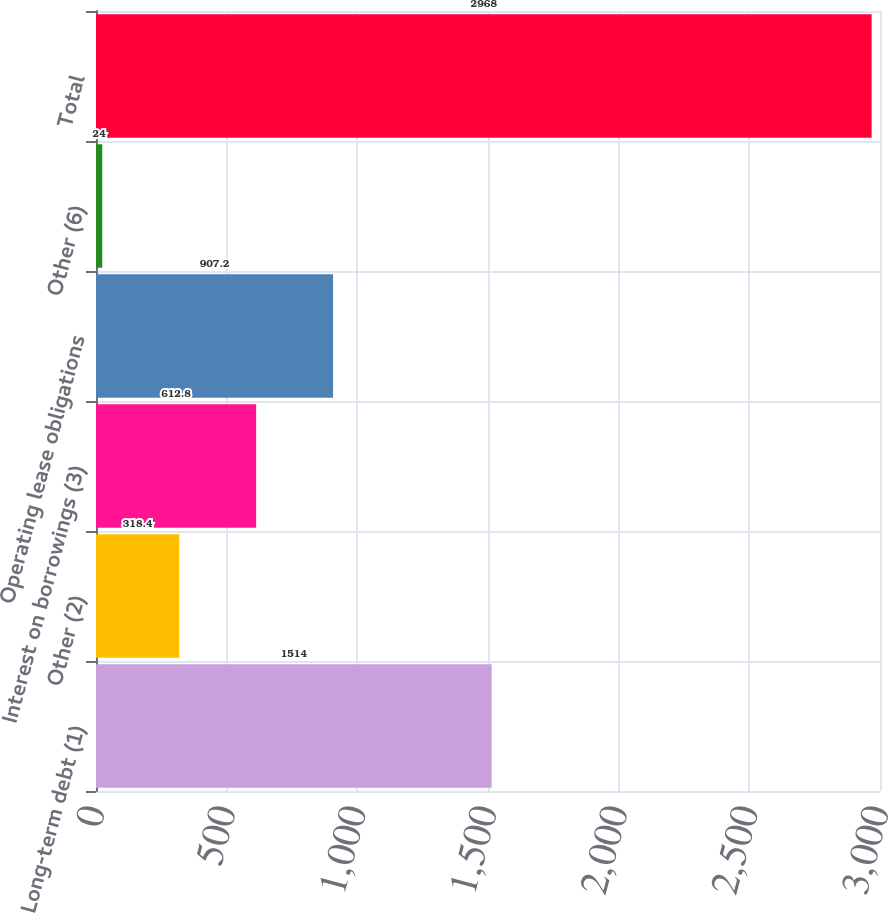Convert chart to OTSL. <chart><loc_0><loc_0><loc_500><loc_500><bar_chart><fcel>Long-term debt (1)<fcel>Other (2)<fcel>Interest on borrowings (3)<fcel>Operating lease obligations<fcel>Other (6)<fcel>Total<nl><fcel>1514<fcel>318.4<fcel>612.8<fcel>907.2<fcel>24<fcel>2968<nl></chart> 